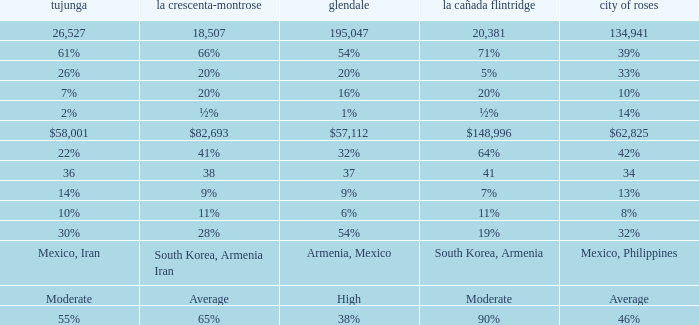What is the percentage of Glendale when Pasadena is 14%? 1%. 